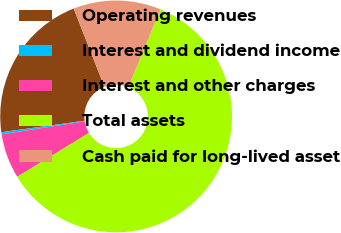Convert chart to OTSL. <chart><loc_0><loc_0><loc_500><loc_500><pie_chart><fcel>Operating revenues<fcel>Interest and dividend income<fcel>Interest and other charges<fcel>Total assets<fcel>Cash paid for long-lived asset<nl><fcel>21.22%<fcel>0.29%<fcel>6.26%<fcel>60.01%<fcel>12.23%<nl></chart> 